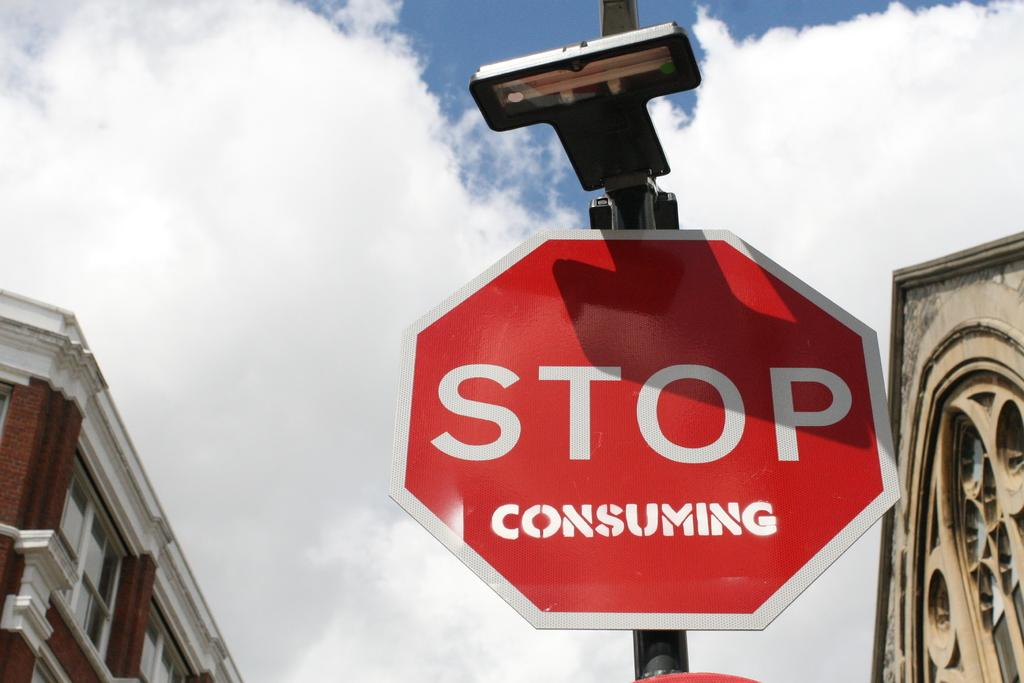<image>
Summarize the visual content of the image. A red stop consuming sign with clouds in the background 